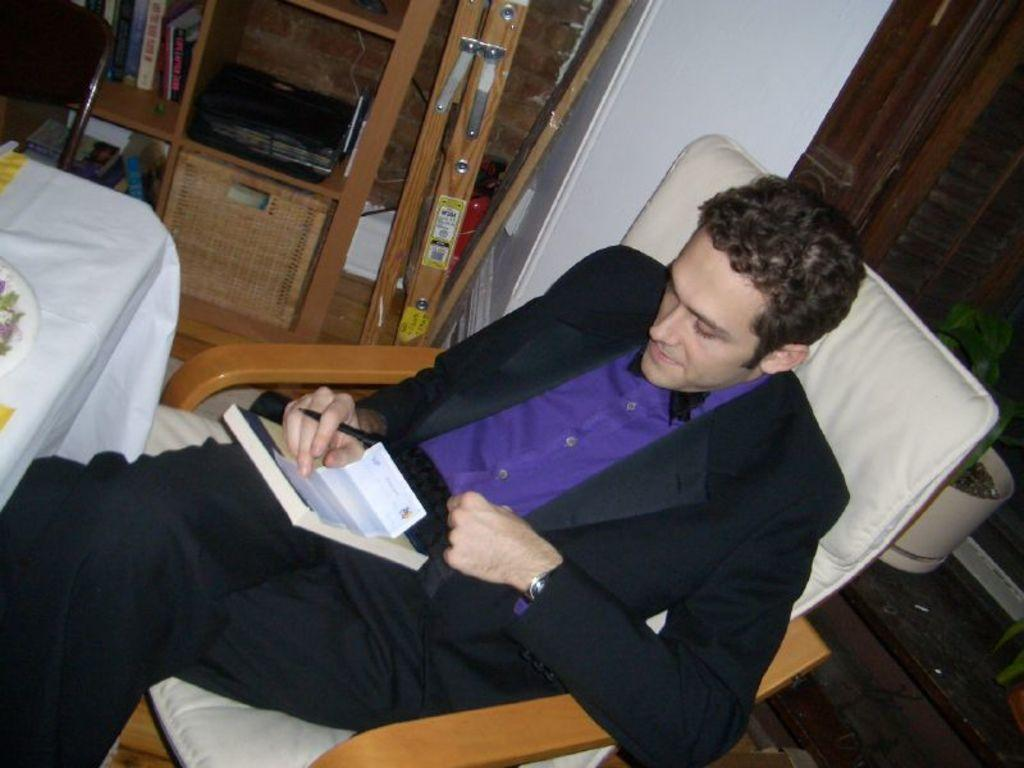What is the person in the image doing? The person is sitting on a chair in the image. What type of furniture is present in the image besides the chair? There is a wooden drawer and a table in the image. What other objects can be seen in the image? There are boxes in the image. What type of cup is being used to destroy the property in the image? There is no cup or destruction of property present in the image. 